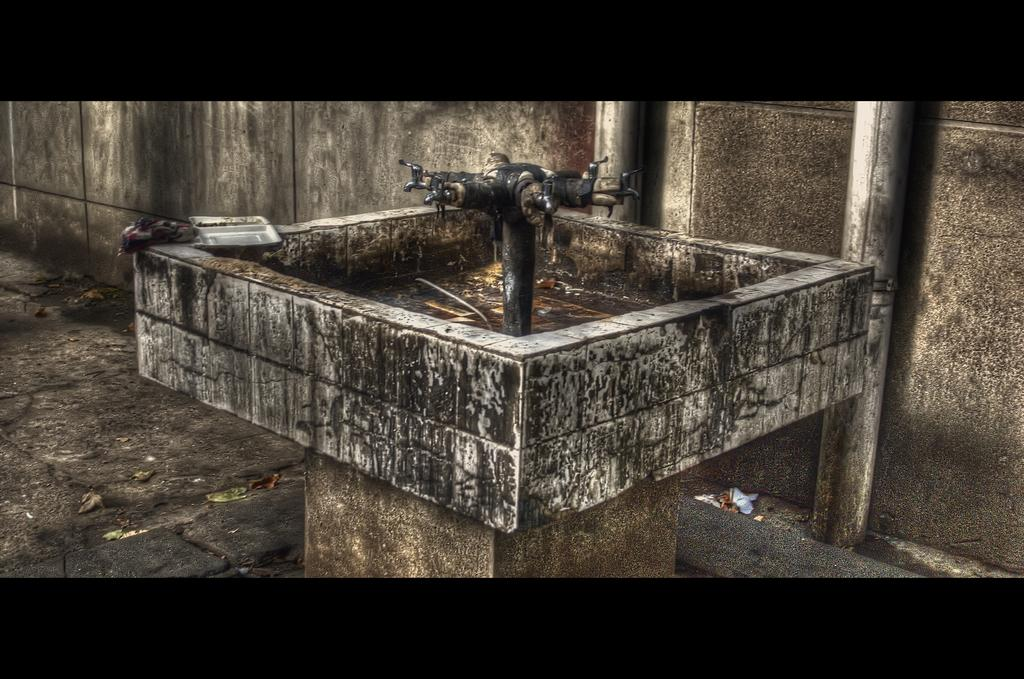What is the main fixture in the image? There is a sink in the image. What is used to control the flow of water in the sink? There are taps in the image. Can you describe the color scheme of the background in the image? The background of the image includes a wall with gray and black colors. How many crates are stacked next to the sink in the image? There are no crates present in the image. What type of wash can be seen being performed in the image? There is no washing activity depicted in the image; it only shows a sink and taps. 